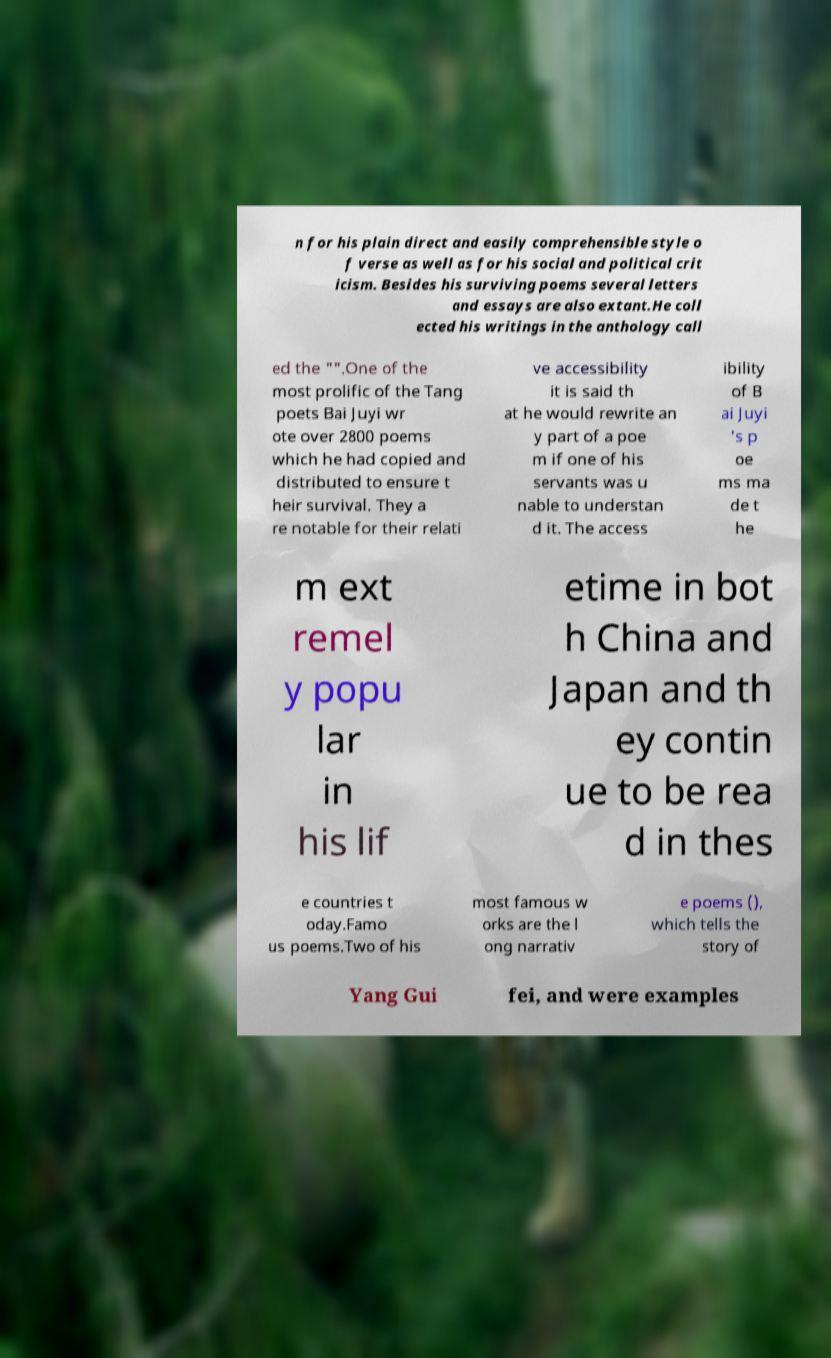Can you read and provide the text displayed in the image?This photo seems to have some interesting text. Can you extract and type it out for me? n for his plain direct and easily comprehensible style o f verse as well as for his social and political crit icism. Besides his surviving poems several letters and essays are also extant.He coll ected his writings in the anthology call ed the "".One of the most prolific of the Tang poets Bai Juyi wr ote over 2800 poems which he had copied and distributed to ensure t heir survival. They a re notable for their relati ve accessibility it is said th at he would rewrite an y part of a poe m if one of his servants was u nable to understan d it. The access ibility of B ai Juyi 's p oe ms ma de t he m ext remel y popu lar in his lif etime in bot h China and Japan and th ey contin ue to be rea d in thes e countries t oday.Famo us poems.Two of his most famous w orks are the l ong narrativ e poems (), which tells the story of Yang Gui fei, and were examples 